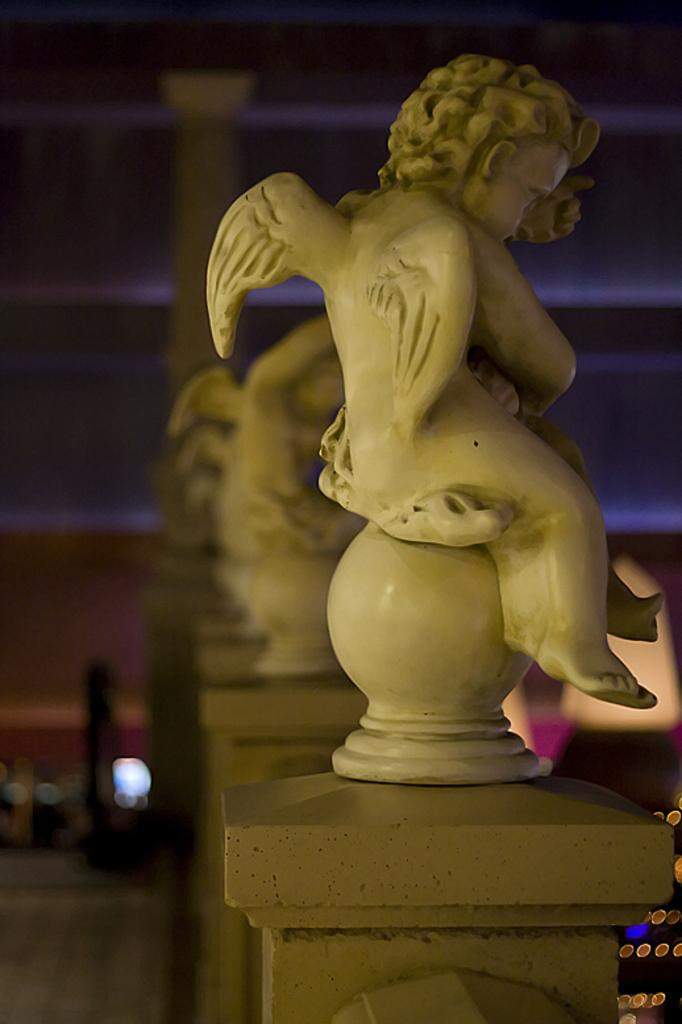What is the main subject of the image? There is a sculpture of a person with wings in the image. Can you describe the background of the image? The background of the image is blurred. What type of crime is being committed in the image? There is no crime being committed in the image; it features a sculpture of a person with wings and a blurred background. How many houses are visible in the image? There are no houses visible in the image. 